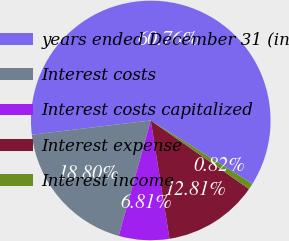<chart> <loc_0><loc_0><loc_500><loc_500><pie_chart><fcel>years ended December 31 (in<fcel>Interest costs<fcel>Interest costs capitalized<fcel>Interest expense<fcel>Interest income<nl><fcel>60.77%<fcel>18.8%<fcel>6.81%<fcel>12.81%<fcel>0.82%<nl></chart> 